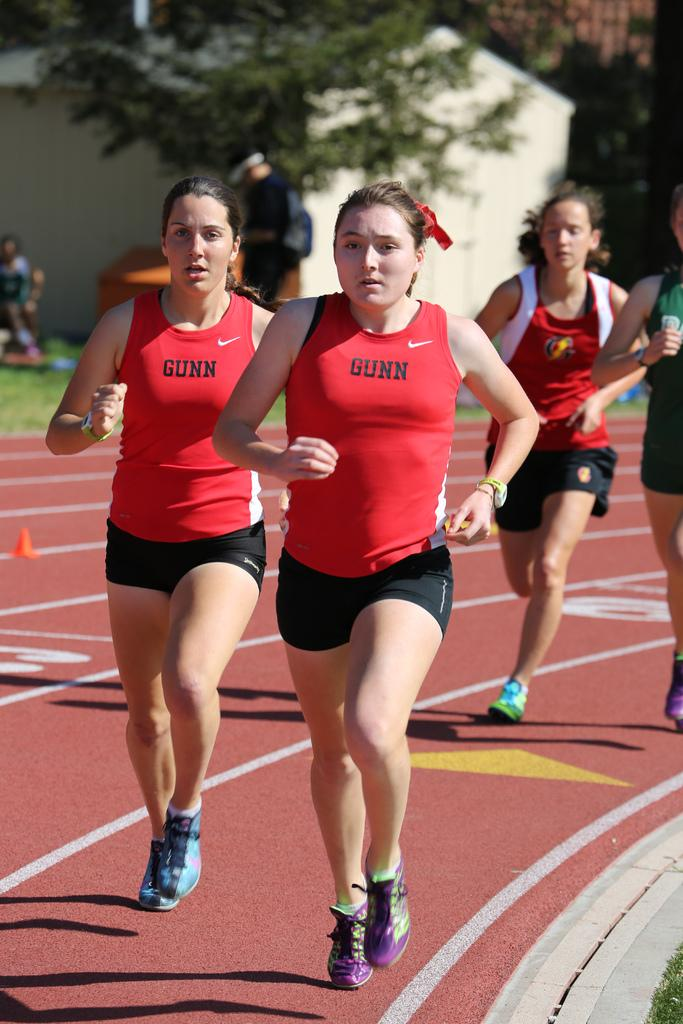What are the persons in the image doing? The persons in the image are running on the ground. What can be seen in the background of the image? There is a house, trees, and other persons in the background of the image. Are there any other objects visible in the background? Yes, there are other objects in the background of the image. What type of nut can be seen being smashed by a hammer in the image? There is no nut or hammer present in the image; it features persons running on the ground and a background with a house, trees, and other persons. What scent can be detected from the image? The image does not provide any information about scents, as it is a visual representation. 